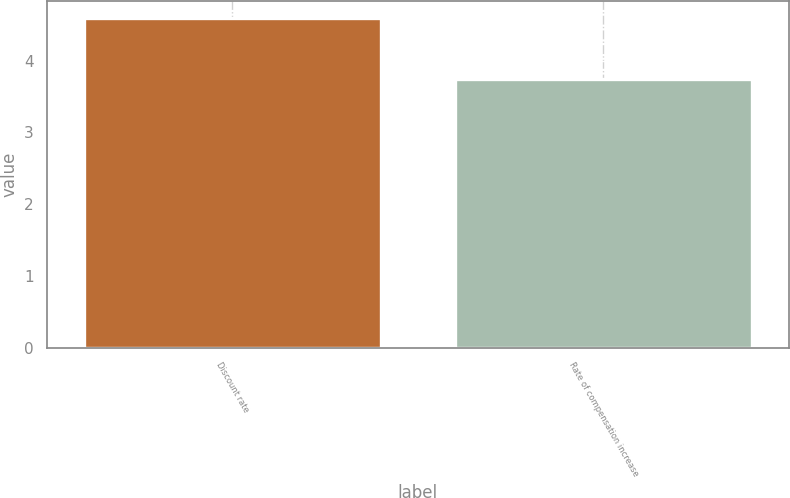Convert chart to OTSL. <chart><loc_0><loc_0><loc_500><loc_500><bar_chart><fcel>Discount rate<fcel>Rate of compensation increase<nl><fcel>4.6<fcel>3.75<nl></chart> 